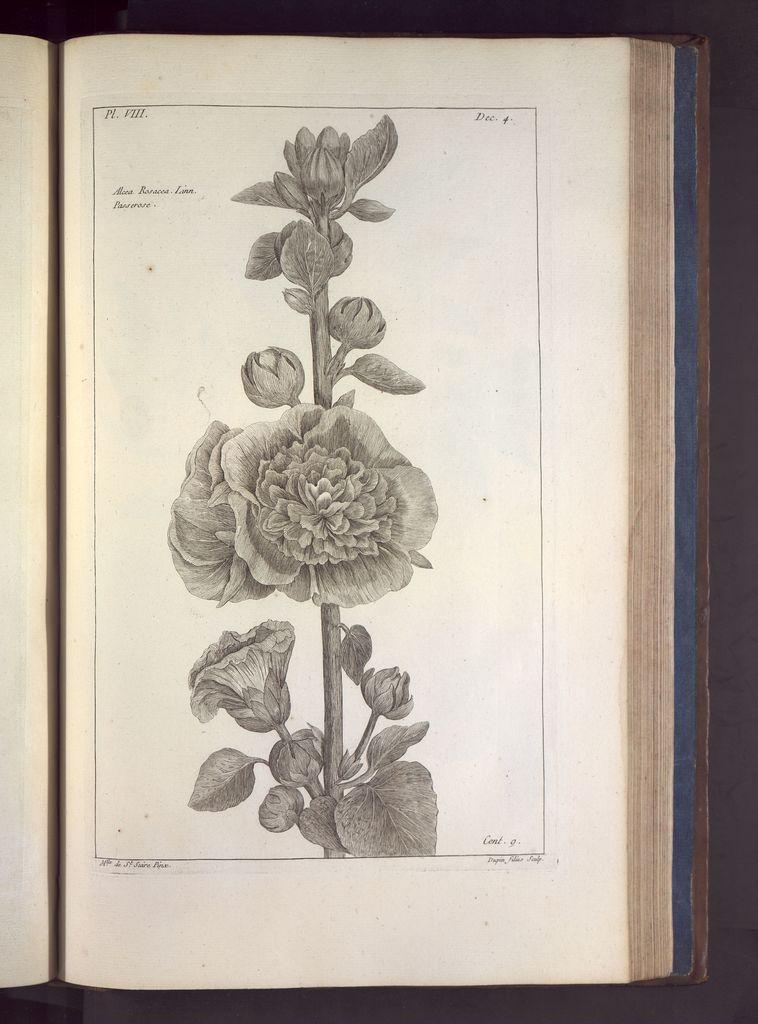What is the main object in the image? There is a book in the image. What is inside the book? The book contains a painting. What is the subject of the painting? The painting depicts a stem. What other elements are present in the painting? There are flowers, buds, and leaves in the painting. How many clocks are visible in the painting? There are no clocks present in the painting; it depicts a stem, flowers, buds, and leaves. 